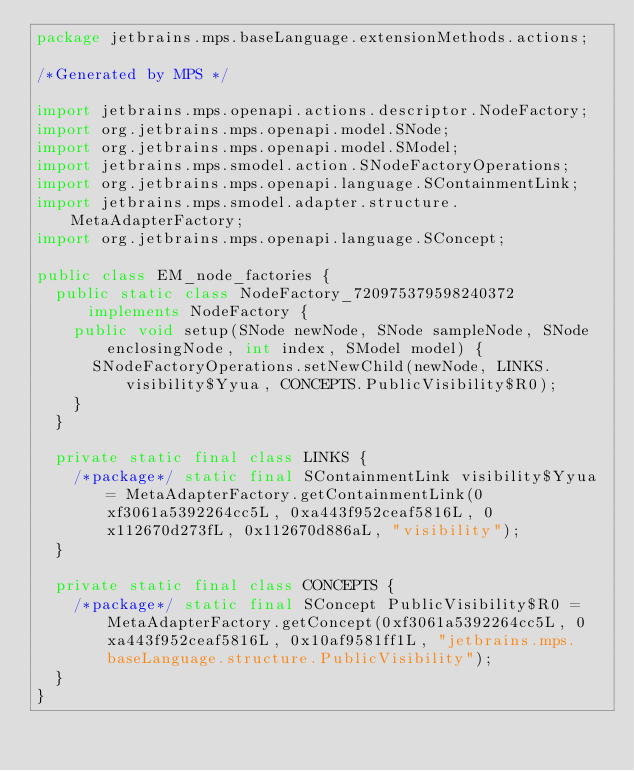<code> <loc_0><loc_0><loc_500><loc_500><_Java_>package jetbrains.mps.baseLanguage.extensionMethods.actions;

/*Generated by MPS */

import jetbrains.mps.openapi.actions.descriptor.NodeFactory;
import org.jetbrains.mps.openapi.model.SNode;
import org.jetbrains.mps.openapi.model.SModel;
import jetbrains.mps.smodel.action.SNodeFactoryOperations;
import org.jetbrains.mps.openapi.language.SContainmentLink;
import jetbrains.mps.smodel.adapter.structure.MetaAdapterFactory;
import org.jetbrains.mps.openapi.language.SConcept;

public class EM_node_factories {
  public static class NodeFactory_720975379598240372 implements NodeFactory {
    public void setup(SNode newNode, SNode sampleNode, SNode enclosingNode, int index, SModel model) {
      SNodeFactoryOperations.setNewChild(newNode, LINKS.visibility$Yyua, CONCEPTS.PublicVisibility$R0);
    }
  }

  private static final class LINKS {
    /*package*/ static final SContainmentLink visibility$Yyua = MetaAdapterFactory.getContainmentLink(0xf3061a5392264cc5L, 0xa443f952ceaf5816L, 0x112670d273fL, 0x112670d886aL, "visibility");
  }

  private static final class CONCEPTS {
    /*package*/ static final SConcept PublicVisibility$R0 = MetaAdapterFactory.getConcept(0xf3061a5392264cc5L, 0xa443f952ceaf5816L, 0x10af9581ff1L, "jetbrains.mps.baseLanguage.structure.PublicVisibility");
  }
}
</code> 